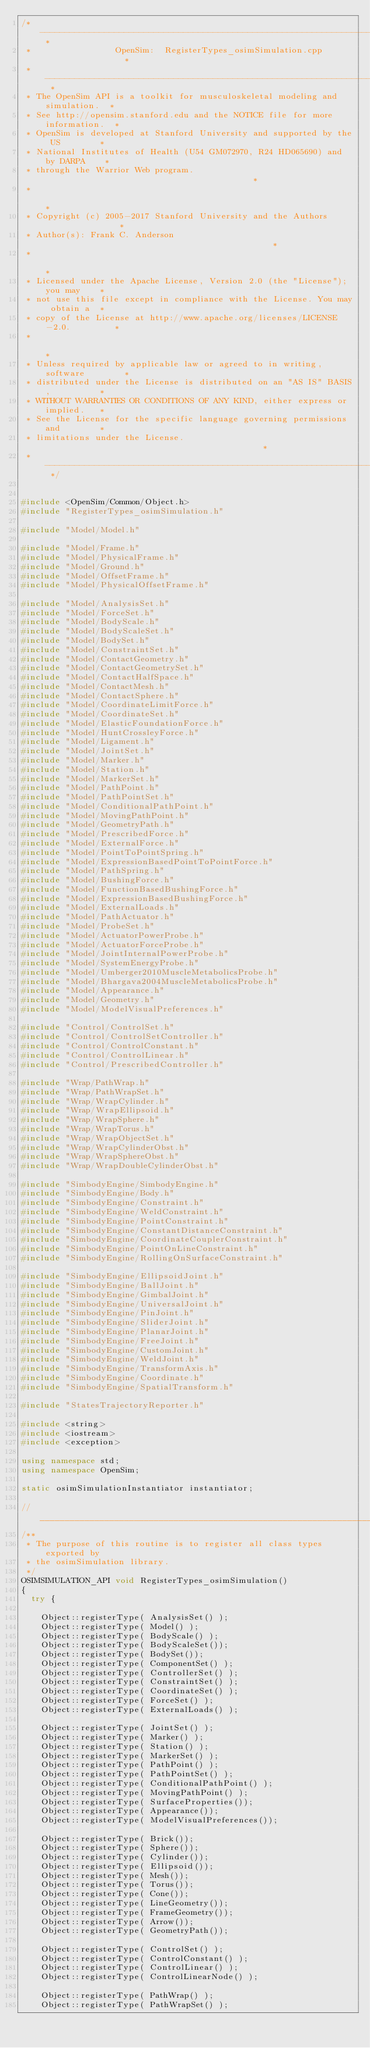Convert code to text. <code><loc_0><loc_0><loc_500><loc_500><_C++_>/* -------------------------------------------------------------------------- *
 *                 OpenSim:  RegisterTypes_osimSimulation.cpp                 *
 * -------------------------------------------------------------------------- *
 * The OpenSim API is a toolkit for musculoskeletal modeling and simulation.  *
 * See http://opensim.stanford.edu and the NOTICE file for more information.  *
 * OpenSim is developed at Stanford University and supported by the US        *
 * National Institutes of Health (U54 GM072970, R24 HD065690) and by DARPA    *
 * through the Warrior Web program.                                           *
 *                                                                            *
 * Copyright (c) 2005-2017 Stanford University and the Authors                *
 * Author(s): Frank C. Anderson                                               *
 *                                                                            *
 * Licensed under the Apache License, Version 2.0 (the "License"); you may    *
 * not use this file except in compliance with the License. You may obtain a  *
 * copy of the License at http://www.apache.org/licenses/LICENSE-2.0.         *
 *                                                                            *
 * Unless required by applicable law or agreed to in writing, software        *
 * distributed under the License is distributed on an "AS IS" BASIS,          *
 * WITHOUT WARRANTIES OR CONDITIONS OF ANY KIND, either express or implied.   *
 * See the License for the specific language governing permissions and        *
 * limitations under the License.                                             *
 * -------------------------------------------------------------------------- */


#include <OpenSim/Common/Object.h>
#include "RegisterTypes_osimSimulation.h"

#include "Model/Model.h"

#include "Model/Frame.h"
#include "Model/PhysicalFrame.h"
#include "Model/Ground.h"
#include "Model/OffsetFrame.h"
#include "Model/PhysicalOffsetFrame.h"

#include "Model/AnalysisSet.h"
#include "Model/ForceSet.h"
#include "Model/BodyScale.h"
#include "Model/BodyScaleSet.h"
#include "Model/BodySet.h"
#include "Model/ConstraintSet.h"
#include "Model/ContactGeometry.h"
#include "Model/ContactGeometrySet.h"
#include "Model/ContactHalfSpace.h"
#include "Model/ContactMesh.h"
#include "Model/ContactSphere.h"
#include "Model/CoordinateLimitForce.h"
#include "Model/CoordinateSet.h"
#include "Model/ElasticFoundationForce.h"
#include "Model/HuntCrossleyForce.h"
#include "Model/Ligament.h"
#include "Model/JointSet.h"
#include "Model/Marker.h"
#include "Model/Station.h"
#include "Model/MarkerSet.h"
#include "Model/PathPoint.h"
#include "Model/PathPointSet.h"
#include "Model/ConditionalPathPoint.h"
#include "Model/MovingPathPoint.h"
#include "Model/GeometryPath.h"
#include "Model/PrescribedForce.h"
#include "Model/ExternalForce.h"
#include "Model/PointToPointSpring.h"
#include "Model/ExpressionBasedPointToPointForce.h"
#include "Model/PathSpring.h"
#include "Model/BushingForce.h"
#include "Model/FunctionBasedBushingForce.h"
#include "Model/ExpressionBasedBushingForce.h"
#include "Model/ExternalLoads.h"
#include "Model/PathActuator.h"
#include "Model/ProbeSet.h"
#include "Model/ActuatorPowerProbe.h"
#include "Model/ActuatorForceProbe.h"
#include "Model/JointInternalPowerProbe.h"
#include "Model/SystemEnergyProbe.h"
#include "Model/Umberger2010MuscleMetabolicsProbe.h"
#include "Model/Bhargava2004MuscleMetabolicsProbe.h"
#include "Model/Appearance.h"
#include "Model/Geometry.h"
#include "Model/ModelVisualPreferences.h"

#include "Control/ControlSet.h"
#include "Control/ControlSetController.h"
#include "Control/ControlConstant.h"
#include "Control/ControlLinear.h"
#include "Control/PrescribedController.h"

#include "Wrap/PathWrap.h"
#include "Wrap/PathWrapSet.h"
#include "Wrap/WrapCylinder.h"
#include "Wrap/WrapEllipsoid.h"
#include "Wrap/WrapSphere.h"
#include "Wrap/WrapTorus.h"
#include "Wrap/WrapObjectSet.h"
#include "Wrap/WrapCylinderObst.h"
#include "Wrap/WrapSphereObst.h"
#include "Wrap/WrapDoubleCylinderObst.h"

#include "SimbodyEngine/SimbodyEngine.h"
#include "SimbodyEngine/Body.h"
#include "SimbodyEngine/Constraint.h"
#include "SimbodyEngine/WeldConstraint.h"
#include "SimbodyEngine/PointConstraint.h"
#include "SimbodyEngine/ConstantDistanceConstraint.h"
#include "SimbodyEngine/CoordinateCouplerConstraint.h"
#include "SimbodyEngine/PointOnLineConstraint.h"
#include "SimbodyEngine/RollingOnSurfaceConstraint.h"

#include "SimbodyEngine/EllipsoidJoint.h"
#include "SimbodyEngine/BallJoint.h"
#include "SimbodyEngine/GimbalJoint.h"
#include "SimbodyEngine/UniversalJoint.h"
#include "SimbodyEngine/PinJoint.h"
#include "SimbodyEngine/SliderJoint.h"
#include "SimbodyEngine/PlanarJoint.h"
#include "SimbodyEngine/FreeJoint.h"
#include "SimbodyEngine/CustomJoint.h"
#include "SimbodyEngine/WeldJoint.h"
#include "SimbodyEngine/TransformAxis.h"
#include "SimbodyEngine/Coordinate.h"
#include "SimbodyEngine/SpatialTransform.h"

#include "StatesTrajectoryReporter.h"

#include <string>
#include <iostream>
#include <exception>

using namespace std;
using namespace OpenSim;

static osimSimulationInstantiator instantiator; 

//_____________________________________________________________________________
/**
 * The purpose of this routine is to register all class types exported by
 * the osimSimulation library.
 */
OSIMSIMULATION_API void RegisterTypes_osimSimulation()
{
  try {

    Object::registerType( AnalysisSet() );
    Object::registerType( Model() );
    Object::registerType( BodyScale() );
    Object::registerType( BodyScaleSet());
    Object::registerType( BodySet());
    Object::registerType( ComponentSet() );
    Object::registerType( ControllerSet() );
    Object::registerType( ConstraintSet() );
    Object::registerType( CoordinateSet() );
    Object::registerType( ForceSet() );
    Object::registerType( ExternalLoads() );

    Object::registerType( JointSet() );
    Object::registerType( Marker() );
    Object::registerType( Station() );
    Object::registerType( MarkerSet() );
    Object::registerType( PathPoint() );
    Object::registerType( PathPointSet() );
    Object::registerType( ConditionalPathPoint() );
    Object::registerType( MovingPathPoint() );
    Object::registerType( SurfaceProperties());
    Object::registerType( Appearance());
    Object::registerType( ModelVisualPreferences());

    Object::registerType( Brick());
    Object::registerType( Sphere());
    Object::registerType( Cylinder());
    Object::registerType( Ellipsoid());
    Object::registerType( Mesh());
    Object::registerType( Torus());
    Object::registerType( Cone());
    Object::registerType( LineGeometry());
    Object::registerType( FrameGeometry());
    Object::registerType( Arrow());
    Object::registerType( GeometryPath());

    Object::registerType( ControlSet() );
    Object::registerType( ControlConstant() );
    Object::registerType( ControlLinear() );
    Object::registerType( ControlLinearNode() );

    Object::registerType( PathWrap() );
    Object::registerType( PathWrapSet() );</code> 